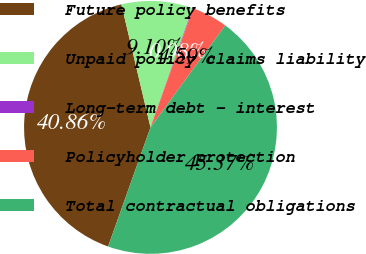<chart> <loc_0><loc_0><loc_500><loc_500><pie_chart><fcel>Future policy benefits<fcel>Unpaid policy claims liability<fcel>Long-term debt - interest<fcel>Policyholder protection<fcel>Total contractual obligations<nl><fcel>40.86%<fcel>9.1%<fcel>0.08%<fcel>4.59%<fcel>45.37%<nl></chart> 